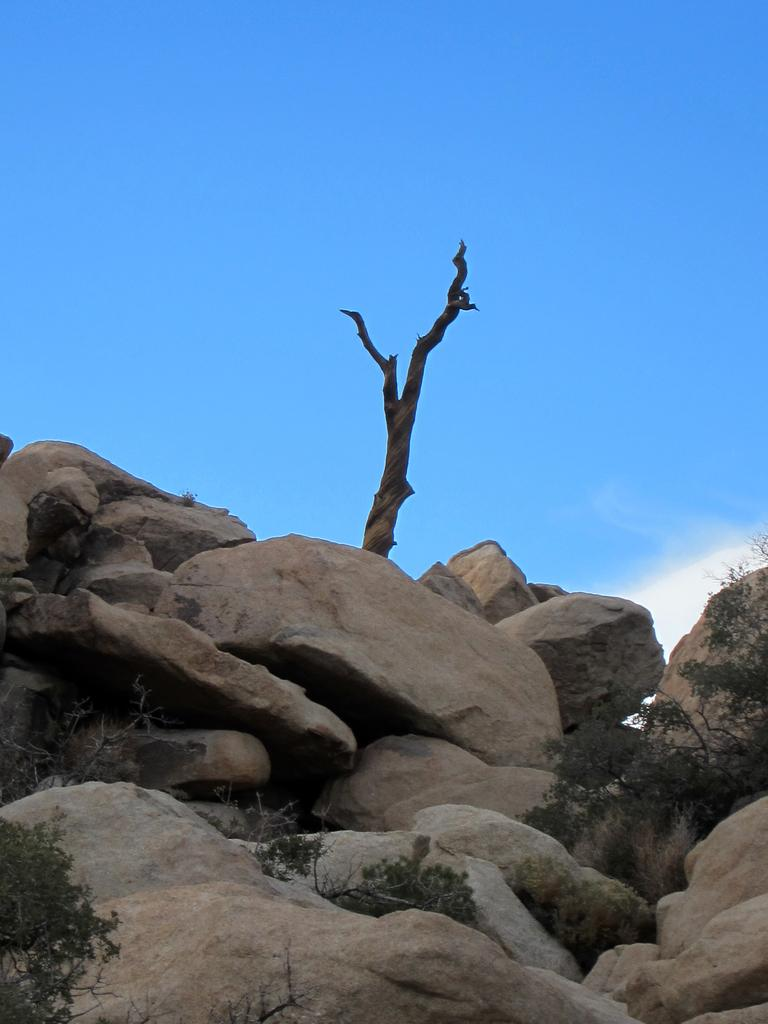What can be found in the middle of the image? There are rocks and trees in the middle of the image. What is visible in the sky at the top of the image? Clouds and the sky are visible at the top of the image. How many horses are grazing on the rocks in the image? There are no horses present in the image; it features rocks and trees. What suggestion is being made by the rocks in the image? The rocks in the image are not making any suggestions, as they are inanimate objects. 